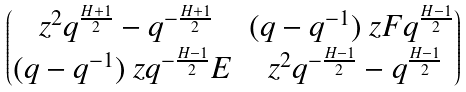Convert formula to latex. <formula><loc_0><loc_0><loc_500><loc_500>\begin{pmatrix} \ z ^ { 2 } q ^ { \frac { H + 1 } 2 } - q ^ { - \frac { H + 1 } 2 } & ( q - q ^ { - 1 } ) \ z F q ^ { \frac { H - 1 } 2 } \\ ( q - q ^ { - 1 } ) \ z q ^ { - \frac { H - 1 } 2 } E & \ z ^ { 2 } q ^ { - \frac { H - 1 } 2 } - q ^ { \frac { H - 1 } 2 } \end{pmatrix}</formula> 